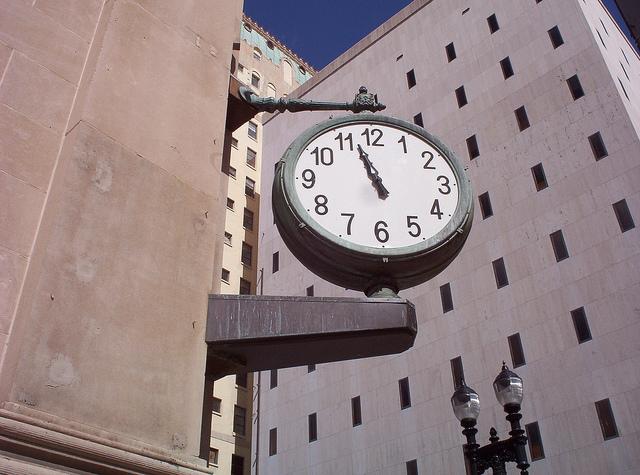What is the minimum height of the white building?
Quick response, please. 7 stories. What is the wall made of?
Answer briefly. Concrete. Is it daytime?
Answer briefly. Yes. Does the building in the background have a fire escape?
Quick response, please. No. What time does the clock show?
Short answer required. 11:55. How is the clock also a landmark?
Answer briefly. Age. What kind of numbers are on the clock?
Short answer required. Numeric. What style of numbers are on the clock face?
Keep it brief. Arabic. Is it almost noon, or almost midnight?
Be succinct. Noon. Does this wall look like brick?
Concise answer only. No. 